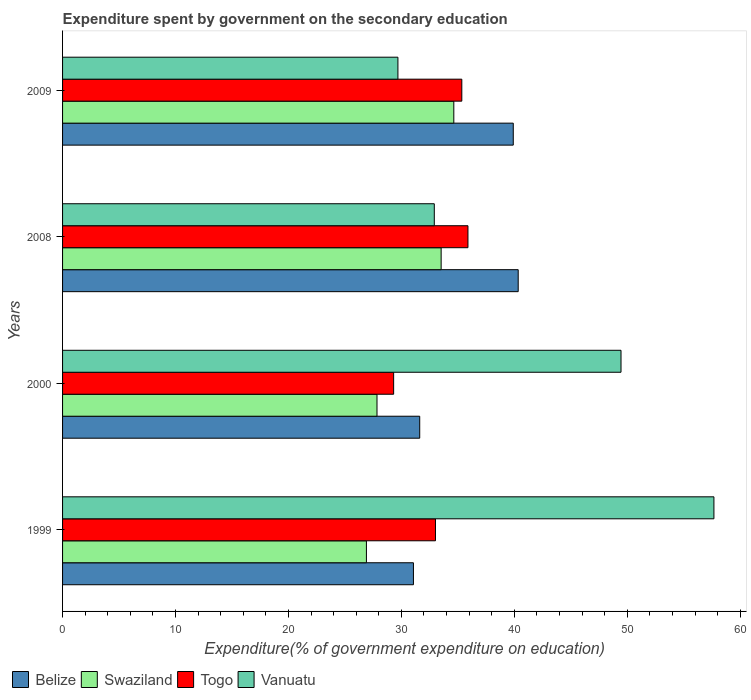How many different coloured bars are there?
Give a very brief answer. 4. Are the number of bars on each tick of the Y-axis equal?
Keep it short and to the point. Yes. How many bars are there on the 3rd tick from the bottom?
Give a very brief answer. 4. What is the label of the 4th group of bars from the top?
Keep it short and to the point. 1999. What is the expenditure spent by government on the secondary education in Swaziland in 2009?
Ensure brevity in your answer.  34.64. Across all years, what is the maximum expenditure spent by government on the secondary education in Swaziland?
Your response must be concise. 34.64. Across all years, what is the minimum expenditure spent by government on the secondary education in Belize?
Provide a succinct answer. 31.07. What is the total expenditure spent by government on the secondary education in Vanuatu in the graph?
Ensure brevity in your answer.  169.73. What is the difference between the expenditure spent by government on the secondary education in Togo in 1999 and that in 2008?
Your answer should be very brief. -2.87. What is the difference between the expenditure spent by government on the secondary education in Togo in 2000 and the expenditure spent by government on the secondary education in Vanuatu in 2008?
Provide a succinct answer. -3.6. What is the average expenditure spent by government on the secondary education in Belize per year?
Make the answer very short. 35.74. In the year 2000, what is the difference between the expenditure spent by government on the secondary education in Togo and expenditure spent by government on the secondary education in Vanuatu?
Offer a terse response. -20.13. In how many years, is the expenditure spent by government on the secondary education in Swaziland greater than 58 %?
Keep it short and to the point. 0. What is the ratio of the expenditure spent by government on the secondary education in Vanuatu in 1999 to that in 2000?
Your response must be concise. 1.17. Is the expenditure spent by government on the secondary education in Belize in 1999 less than that in 2000?
Your answer should be very brief. Yes. What is the difference between the highest and the second highest expenditure spent by government on the secondary education in Togo?
Your answer should be compact. 0.54. What is the difference between the highest and the lowest expenditure spent by government on the secondary education in Vanuatu?
Offer a terse response. 27.98. What does the 3rd bar from the top in 2000 represents?
Your answer should be compact. Swaziland. What does the 1st bar from the bottom in 2009 represents?
Make the answer very short. Belize. How many years are there in the graph?
Your answer should be very brief. 4. What is the difference between two consecutive major ticks on the X-axis?
Your response must be concise. 10. Does the graph contain any zero values?
Provide a short and direct response. No. Does the graph contain grids?
Provide a short and direct response. No. Where does the legend appear in the graph?
Offer a terse response. Bottom left. How many legend labels are there?
Your answer should be very brief. 4. What is the title of the graph?
Provide a short and direct response. Expenditure spent by government on the secondary education. Does "Greece" appear as one of the legend labels in the graph?
Offer a very short reply. No. What is the label or title of the X-axis?
Offer a terse response. Expenditure(% of government expenditure on education). What is the label or title of the Y-axis?
Provide a short and direct response. Years. What is the Expenditure(% of government expenditure on education) of Belize in 1999?
Offer a terse response. 31.07. What is the Expenditure(% of government expenditure on education) of Swaziland in 1999?
Provide a succinct answer. 26.9. What is the Expenditure(% of government expenditure on education) of Togo in 1999?
Provide a short and direct response. 33.02. What is the Expenditure(% of government expenditure on education) in Vanuatu in 1999?
Provide a short and direct response. 57.67. What is the Expenditure(% of government expenditure on education) of Belize in 2000?
Your response must be concise. 31.62. What is the Expenditure(% of government expenditure on education) in Swaziland in 2000?
Ensure brevity in your answer.  27.84. What is the Expenditure(% of government expenditure on education) in Togo in 2000?
Your answer should be compact. 29.31. What is the Expenditure(% of government expenditure on education) of Vanuatu in 2000?
Provide a succinct answer. 49.45. What is the Expenditure(% of government expenditure on education) of Belize in 2008?
Offer a terse response. 40.34. What is the Expenditure(% of government expenditure on education) in Swaziland in 2008?
Provide a short and direct response. 33.52. What is the Expenditure(% of government expenditure on education) of Togo in 2008?
Keep it short and to the point. 35.89. What is the Expenditure(% of government expenditure on education) in Vanuatu in 2008?
Offer a terse response. 32.91. What is the Expenditure(% of government expenditure on education) in Belize in 2009?
Your answer should be compact. 39.91. What is the Expenditure(% of government expenditure on education) of Swaziland in 2009?
Offer a terse response. 34.64. What is the Expenditure(% of government expenditure on education) in Togo in 2009?
Your response must be concise. 35.35. What is the Expenditure(% of government expenditure on education) of Vanuatu in 2009?
Your answer should be very brief. 29.69. Across all years, what is the maximum Expenditure(% of government expenditure on education) of Belize?
Keep it short and to the point. 40.34. Across all years, what is the maximum Expenditure(% of government expenditure on education) in Swaziland?
Provide a short and direct response. 34.64. Across all years, what is the maximum Expenditure(% of government expenditure on education) of Togo?
Provide a succinct answer. 35.89. Across all years, what is the maximum Expenditure(% of government expenditure on education) in Vanuatu?
Provide a short and direct response. 57.67. Across all years, what is the minimum Expenditure(% of government expenditure on education) of Belize?
Your response must be concise. 31.07. Across all years, what is the minimum Expenditure(% of government expenditure on education) in Swaziland?
Offer a very short reply. 26.9. Across all years, what is the minimum Expenditure(% of government expenditure on education) of Togo?
Provide a succinct answer. 29.31. Across all years, what is the minimum Expenditure(% of government expenditure on education) in Vanuatu?
Your response must be concise. 29.69. What is the total Expenditure(% of government expenditure on education) of Belize in the graph?
Provide a short and direct response. 142.94. What is the total Expenditure(% of government expenditure on education) in Swaziland in the graph?
Ensure brevity in your answer.  122.91. What is the total Expenditure(% of government expenditure on education) in Togo in the graph?
Keep it short and to the point. 133.58. What is the total Expenditure(% of government expenditure on education) of Vanuatu in the graph?
Give a very brief answer. 169.73. What is the difference between the Expenditure(% of government expenditure on education) in Belize in 1999 and that in 2000?
Your answer should be very brief. -0.56. What is the difference between the Expenditure(% of government expenditure on education) in Swaziland in 1999 and that in 2000?
Give a very brief answer. -0.94. What is the difference between the Expenditure(% of government expenditure on education) of Togo in 1999 and that in 2000?
Your response must be concise. 3.71. What is the difference between the Expenditure(% of government expenditure on education) of Vanuatu in 1999 and that in 2000?
Your response must be concise. 8.23. What is the difference between the Expenditure(% of government expenditure on education) in Belize in 1999 and that in 2008?
Keep it short and to the point. -9.28. What is the difference between the Expenditure(% of government expenditure on education) in Swaziland in 1999 and that in 2008?
Provide a short and direct response. -6.62. What is the difference between the Expenditure(% of government expenditure on education) in Togo in 1999 and that in 2008?
Your response must be concise. -2.87. What is the difference between the Expenditure(% of government expenditure on education) in Vanuatu in 1999 and that in 2008?
Keep it short and to the point. 24.76. What is the difference between the Expenditure(% of government expenditure on education) in Belize in 1999 and that in 2009?
Your answer should be compact. -8.84. What is the difference between the Expenditure(% of government expenditure on education) in Swaziland in 1999 and that in 2009?
Keep it short and to the point. -7.74. What is the difference between the Expenditure(% of government expenditure on education) in Togo in 1999 and that in 2009?
Give a very brief answer. -2.33. What is the difference between the Expenditure(% of government expenditure on education) in Vanuatu in 1999 and that in 2009?
Your response must be concise. 27.98. What is the difference between the Expenditure(% of government expenditure on education) in Belize in 2000 and that in 2008?
Give a very brief answer. -8.72. What is the difference between the Expenditure(% of government expenditure on education) in Swaziland in 2000 and that in 2008?
Make the answer very short. -5.68. What is the difference between the Expenditure(% of government expenditure on education) of Togo in 2000 and that in 2008?
Your answer should be compact. -6.58. What is the difference between the Expenditure(% of government expenditure on education) of Vanuatu in 2000 and that in 2008?
Your answer should be compact. 16.53. What is the difference between the Expenditure(% of government expenditure on education) of Belize in 2000 and that in 2009?
Offer a terse response. -8.28. What is the difference between the Expenditure(% of government expenditure on education) in Swaziland in 2000 and that in 2009?
Make the answer very short. -6.8. What is the difference between the Expenditure(% of government expenditure on education) in Togo in 2000 and that in 2009?
Keep it short and to the point. -6.04. What is the difference between the Expenditure(% of government expenditure on education) in Vanuatu in 2000 and that in 2009?
Provide a short and direct response. 19.75. What is the difference between the Expenditure(% of government expenditure on education) of Belize in 2008 and that in 2009?
Make the answer very short. 0.44. What is the difference between the Expenditure(% of government expenditure on education) in Swaziland in 2008 and that in 2009?
Ensure brevity in your answer.  -1.12. What is the difference between the Expenditure(% of government expenditure on education) in Togo in 2008 and that in 2009?
Keep it short and to the point. 0.54. What is the difference between the Expenditure(% of government expenditure on education) in Vanuatu in 2008 and that in 2009?
Ensure brevity in your answer.  3.22. What is the difference between the Expenditure(% of government expenditure on education) of Belize in 1999 and the Expenditure(% of government expenditure on education) of Swaziland in 2000?
Ensure brevity in your answer.  3.23. What is the difference between the Expenditure(% of government expenditure on education) in Belize in 1999 and the Expenditure(% of government expenditure on education) in Togo in 2000?
Make the answer very short. 1.75. What is the difference between the Expenditure(% of government expenditure on education) of Belize in 1999 and the Expenditure(% of government expenditure on education) of Vanuatu in 2000?
Your answer should be very brief. -18.38. What is the difference between the Expenditure(% of government expenditure on education) of Swaziland in 1999 and the Expenditure(% of government expenditure on education) of Togo in 2000?
Ensure brevity in your answer.  -2.41. What is the difference between the Expenditure(% of government expenditure on education) in Swaziland in 1999 and the Expenditure(% of government expenditure on education) in Vanuatu in 2000?
Give a very brief answer. -22.54. What is the difference between the Expenditure(% of government expenditure on education) in Togo in 1999 and the Expenditure(% of government expenditure on education) in Vanuatu in 2000?
Keep it short and to the point. -16.43. What is the difference between the Expenditure(% of government expenditure on education) in Belize in 1999 and the Expenditure(% of government expenditure on education) in Swaziland in 2008?
Provide a short and direct response. -2.45. What is the difference between the Expenditure(% of government expenditure on education) in Belize in 1999 and the Expenditure(% of government expenditure on education) in Togo in 2008?
Your response must be concise. -4.83. What is the difference between the Expenditure(% of government expenditure on education) of Belize in 1999 and the Expenditure(% of government expenditure on education) of Vanuatu in 2008?
Provide a succinct answer. -1.85. What is the difference between the Expenditure(% of government expenditure on education) of Swaziland in 1999 and the Expenditure(% of government expenditure on education) of Togo in 2008?
Offer a terse response. -8.99. What is the difference between the Expenditure(% of government expenditure on education) of Swaziland in 1999 and the Expenditure(% of government expenditure on education) of Vanuatu in 2008?
Provide a short and direct response. -6.01. What is the difference between the Expenditure(% of government expenditure on education) in Togo in 1999 and the Expenditure(% of government expenditure on education) in Vanuatu in 2008?
Ensure brevity in your answer.  0.1. What is the difference between the Expenditure(% of government expenditure on education) in Belize in 1999 and the Expenditure(% of government expenditure on education) in Swaziland in 2009?
Give a very brief answer. -3.57. What is the difference between the Expenditure(% of government expenditure on education) of Belize in 1999 and the Expenditure(% of government expenditure on education) of Togo in 2009?
Your response must be concise. -4.28. What is the difference between the Expenditure(% of government expenditure on education) in Belize in 1999 and the Expenditure(% of government expenditure on education) in Vanuatu in 2009?
Your answer should be very brief. 1.37. What is the difference between the Expenditure(% of government expenditure on education) in Swaziland in 1999 and the Expenditure(% of government expenditure on education) in Togo in 2009?
Offer a very short reply. -8.45. What is the difference between the Expenditure(% of government expenditure on education) of Swaziland in 1999 and the Expenditure(% of government expenditure on education) of Vanuatu in 2009?
Offer a terse response. -2.79. What is the difference between the Expenditure(% of government expenditure on education) in Togo in 1999 and the Expenditure(% of government expenditure on education) in Vanuatu in 2009?
Provide a succinct answer. 3.33. What is the difference between the Expenditure(% of government expenditure on education) of Belize in 2000 and the Expenditure(% of government expenditure on education) of Swaziland in 2008?
Your answer should be very brief. -1.9. What is the difference between the Expenditure(% of government expenditure on education) in Belize in 2000 and the Expenditure(% of government expenditure on education) in Togo in 2008?
Offer a very short reply. -4.27. What is the difference between the Expenditure(% of government expenditure on education) of Belize in 2000 and the Expenditure(% of government expenditure on education) of Vanuatu in 2008?
Make the answer very short. -1.29. What is the difference between the Expenditure(% of government expenditure on education) in Swaziland in 2000 and the Expenditure(% of government expenditure on education) in Togo in 2008?
Offer a terse response. -8.05. What is the difference between the Expenditure(% of government expenditure on education) in Swaziland in 2000 and the Expenditure(% of government expenditure on education) in Vanuatu in 2008?
Provide a short and direct response. -5.07. What is the difference between the Expenditure(% of government expenditure on education) in Togo in 2000 and the Expenditure(% of government expenditure on education) in Vanuatu in 2008?
Offer a terse response. -3.6. What is the difference between the Expenditure(% of government expenditure on education) in Belize in 2000 and the Expenditure(% of government expenditure on education) in Swaziland in 2009?
Keep it short and to the point. -3.02. What is the difference between the Expenditure(% of government expenditure on education) in Belize in 2000 and the Expenditure(% of government expenditure on education) in Togo in 2009?
Make the answer very short. -3.73. What is the difference between the Expenditure(% of government expenditure on education) of Belize in 2000 and the Expenditure(% of government expenditure on education) of Vanuatu in 2009?
Give a very brief answer. 1.93. What is the difference between the Expenditure(% of government expenditure on education) of Swaziland in 2000 and the Expenditure(% of government expenditure on education) of Togo in 2009?
Your response must be concise. -7.51. What is the difference between the Expenditure(% of government expenditure on education) in Swaziland in 2000 and the Expenditure(% of government expenditure on education) in Vanuatu in 2009?
Make the answer very short. -1.85. What is the difference between the Expenditure(% of government expenditure on education) in Togo in 2000 and the Expenditure(% of government expenditure on education) in Vanuatu in 2009?
Your answer should be compact. -0.38. What is the difference between the Expenditure(% of government expenditure on education) of Belize in 2008 and the Expenditure(% of government expenditure on education) of Swaziland in 2009?
Your answer should be compact. 5.7. What is the difference between the Expenditure(% of government expenditure on education) of Belize in 2008 and the Expenditure(% of government expenditure on education) of Togo in 2009?
Your response must be concise. 4.99. What is the difference between the Expenditure(% of government expenditure on education) of Belize in 2008 and the Expenditure(% of government expenditure on education) of Vanuatu in 2009?
Give a very brief answer. 10.65. What is the difference between the Expenditure(% of government expenditure on education) in Swaziland in 2008 and the Expenditure(% of government expenditure on education) in Togo in 2009?
Provide a short and direct response. -1.83. What is the difference between the Expenditure(% of government expenditure on education) of Swaziland in 2008 and the Expenditure(% of government expenditure on education) of Vanuatu in 2009?
Give a very brief answer. 3.83. What is the difference between the Expenditure(% of government expenditure on education) of Togo in 2008 and the Expenditure(% of government expenditure on education) of Vanuatu in 2009?
Your answer should be very brief. 6.2. What is the average Expenditure(% of government expenditure on education) in Belize per year?
Keep it short and to the point. 35.74. What is the average Expenditure(% of government expenditure on education) of Swaziland per year?
Provide a short and direct response. 30.73. What is the average Expenditure(% of government expenditure on education) in Togo per year?
Offer a very short reply. 33.39. What is the average Expenditure(% of government expenditure on education) in Vanuatu per year?
Offer a terse response. 42.43. In the year 1999, what is the difference between the Expenditure(% of government expenditure on education) in Belize and Expenditure(% of government expenditure on education) in Swaziland?
Your answer should be compact. 4.16. In the year 1999, what is the difference between the Expenditure(% of government expenditure on education) of Belize and Expenditure(% of government expenditure on education) of Togo?
Your answer should be very brief. -1.95. In the year 1999, what is the difference between the Expenditure(% of government expenditure on education) of Belize and Expenditure(% of government expenditure on education) of Vanuatu?
Offer a terse response. -26.61. In the year 1999, what is the difference between the Expenditure(% of government expenditure on education) of Swaziland and Expenditure(% of government expenditure on education) of Togo?
Your answer should be very brief. -6.11. In the year 1999, what is the difference between the Expenditure(% of government expenditure on education) of Swaziland and Expenditure(% of government expenditure on education) of Vanuatu?
Offer a terse response. -30.77. In the year 1999, what is the difference between the Expenditure(% of government expenditure on education) in Togo and Expenditure(% of government expenditure on education) in Vanuatu?
Offer a terse response. -24.65. In the year 2000, what is the difference between the Expenditure(% of government expenditure on education) of Belize and Expenditure(% of government expenditure on education) of Swaziland?
Your response must be concise. 3.78. In the year 2000, what is the difference between the Expenditure(% of government expenditure on education) in Belize and Expenditure(% of government expenditure on education) in Togo?
Your answer should be compact. 2.31. In the year 2000, what is the difference between the Expenditure(% of government expenditure on education) of Belize and Expenditure(% of government expenditure on education) of Vanuatu?
Provide a short and direct response. -17.82. In the year 2000, what is the difference between the Expenditure(% of government expenditure on education) of Swaziland and Expenditure(% of government expenditure on education) of Togo?
Your answer should be compact. -1.47. In the year 2000, what is the difference between the Expenditure(% of government expenditure on education) of Swaziland and Expenditure(% of government expenditure on education) of Vanuatu?
Keep it short and to the point. -21.6. In the year 2000, what is the difference between the Expenditure(% of government expenditure on education) in Togo and Expenditure(% of government expenditure on education) in Vanuatu?
Give a very brief answer. -20.13. In the year 2008, what is the difference between the Expenditure(% of government expenditure on education) of Belize and Expenditure(% of government expenditure on education) of Swaziland?
Your answer should be compact. 6.82. In the year 2008, what is the difference between the Expenditure(% of government expenditure on education) of Belize and Expenditure(% of government expenditure on education) of Togo?
Ensure brevity in your answer.  4.45. In the year 2008, what is the difference between the Expenditure(% of government expenditure on education) of Belize and Expenditure(% of government expenditure on education) of Vanuatu?
Offer a terse response. 7.43. In the year 2008, what is the difference between the Expenditure(% of government expenditure on education) in Swaziland and Expenditure(% of government expenditure on education) in Togo?
Your response must be concise. -2.37. In the year 2008, what is the difference between the Expenditure(% of government expenditure on education) of Swaziland and Expenditure(% of government expenditure on education) of Vanuatu?
Offer a terse response. 0.61. In the year 2008, what is the difference between the Expenditure(% of government expenditure on education) in Togo and Expenditure(% of government expenditure on education) in Vanuatu?
Give a very brief answer. 2.98. In the year 2009, what is the difference between the Expenditure(% of government expenditure on education) in Belize and Expenditure(% of government expenditure on education) in Swaziland?
Provide a short and direct response. 5.26. In the year 2009, what is the difference between the Expenditure(% of government expenditure on education) of Belize and Expenditure(% of government expenditure on education) of Togo?
Your answer should be very brief. 4.56. In the year 2009, what is the difference between the Expenditure(% of government expenditure on education) in Belize and Expenditure(% of government expenditure on education) in Vanuatu?
Your answer should be compact. 10.21. In the year 2009, what is the difference between the Expenditure(% of government expenditure on education) of Swaziland and Expenditure(% of government expenditure on education) of Togo?
Provide a succinct answer. -0.71. In the year 2009, what is the difference between the Expenditure(% of government expenditure on education) in Swaziland and Expenditure(% of government expenditure on education) in Vanuatu?
Ensure brevity in your answer.  4.95. In the year 2009, what is the difference between the Expenditure(% of government expenditure on education) of Togo and Expenditure(% of government expenditure on education) of Vanuatu?
Your answer should be very brief. 5.66. What is the ratio of the Expenditure(% of government expenditure on education) of Belize in 1999 to that in 2000?
Your response must be concise. 0.98. What is the ratio of the Expenditure(% of government expenditure on education) of Swaziland in 1999 to that in 2000?
Provide a short and direct response. 0.97. What is the ratio of the Expenditure(% of government expenditure on education) in Togo in 1999 to that in 2000?
Provide a succinct answer. 1.13. What is the ratio of the Expenditure(% of government expenditure on education) of Vanuatu in 1999 to that in 2000?
Your response must be concise. 1.17. What is the ratio of the Expenditure(% of government expenditure on education) of Belize in 1999 to that in 2008?
Provide a succinct answer. 0.77. What is the ratio of the Expenditure(% of government expenditure on education) of Swaziland in 1999 to that in 2008?
Provide a succinct answer. 0.8. What is the ratio of the Expenditure(% of government expenditure on education) in Togo in 1999 to that in 2008?
Provide a succinct answer. 0.92. What is the ratio of the Expenditure(% of government expenditure on education) in Vanuatu in 1999 to that in 2008?
Provide a succinct answer. 1.75. What is the ratio of the Expenditure(% of government expenditure on education) of Belize in 1999 to that in 2009?
Ensure brevity in your answer.  0.78. What is the ratio of the Expenditure(% of government expenditure on education) of Swaziland in 1999 to that in 2009?
Offer a terse response. 0.78. What is the ratio of the Expenditure(% of government expenditure on education) of Togo in 1999 to that in 2009?
Make the answer very short. 0.93. What is the ratio of the Expenditure(% of government expenditure on education) in Vanuatu in 1999 to that in 2009?
Keep it short and to the point. 1.94. What is the ratio of the Expenditure(% of government expenditure on education) of Belize in 2000 to that in 2008?
Provide a short and direct response. 0.78. What is the ratio of the Expenditure(% of government expenditure on education) of Swaziland in 2000 to that in 2008?
Your answer should be compact. 0.83. What is the ratio of the Expenditure(% of government expenditure on education) of Togo in 2000 to that in 2008?
Provide a succinct answer. 0.82. What is the ratio of the Expenditure(% of government expenditure on education) of Vanuatu in 2000 to that in 2008?
Provide a succinct answer. 1.5. What is the ratio of the Expenditure(% of government expenditure on education) of Belize in 2000 to that in 2009?
Your answer should be very brief. 0.79. What is the ratio of the Expenditure(% of government expenditure on education) in Swaziland in 2000 to that in 2009?
Give a very brief answer. 0.8. What is the ratio of the Expenditure(% of government expenditure on education) of Togo in 2000 to that in 2009?
Make the answer very short. 0.83. What is the ratio of the Expenditure(% of government expenditure on education) of Vanuatu in 2000 to that in 2009?
Provide a short and direct response. 1.67. What is the ratio of the Expenditure(% of government expenditure on education) of Belize in 2008 to that in 2009?
Your response must be concise. 1.01. What is the ratio of the Expenditure(% of government expenditure on education) of Swaziland in 2008 to that in 2009?
Provide a succinct answer. 0.97. What is the ratio of the Expenditure(% of government expenditure on education) in Togo in 2008 to that in 2009?
Provide a short and direct response. 1.02. What is the ratio of the Expenditure(% of government expenditure on education) in Vanuatu in 2008 to that in 2009?
Your answer should be compact. 1.11. What is the difference between the highest and the second highest Expenditure(% of government expenditure on education) of Belize?
Your answer should be very brief. 0.44. What is the difference between the highest and the second highest Expenditure(% of government expenditure on education) of Swaziland?
Offer a very short reply. 1.12. What is the difference between the highest and the second highest Expenditure(% of government expenditure on education) of Togo?
Keep it short and to the point. 0.54. What is the difference between the highest and the second highest Expenditure(% of government expenditure on education) in Vanuatu?
Provide a short and direct response. 8.23. What is the difference between the highest and the lowest Expenditure(% of government expenditure on education) in Belize?
Make the answer very short. 9.28. What is the difference between the highest and the lowest Expenditure(% of government expenditure on education) in Swaziland?
Keep it short and to the point. 7.74. What is the difference between the highest and the lowest Expenditure(% of government expenditure on education) of Togo?
Offer a very short reply. 6.58. What is the difference between the highest and the lowest Expenditure(% of government expenditure on education) in Vanuatu?
Your answer should be very brief. 27.98. 